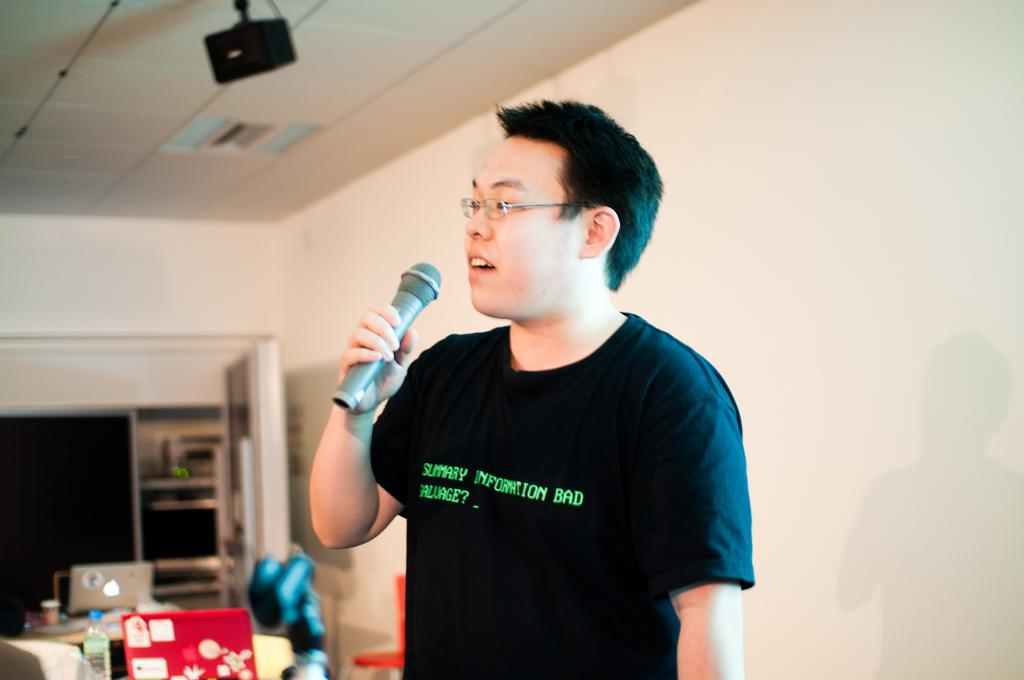What is the man in the image doing? The man is holding a microphone and speaking. What object is the man holding in the image? The man is holding a microphone. What can be seen in the background of the image? There is a table in the background of the image. What items are placed on the table in the image? A laptop and a bottle are placed on the table. What type of pie is being served on the table in the image? There is no pie present in the image; only a laptop and a bottle are placed on the table. 